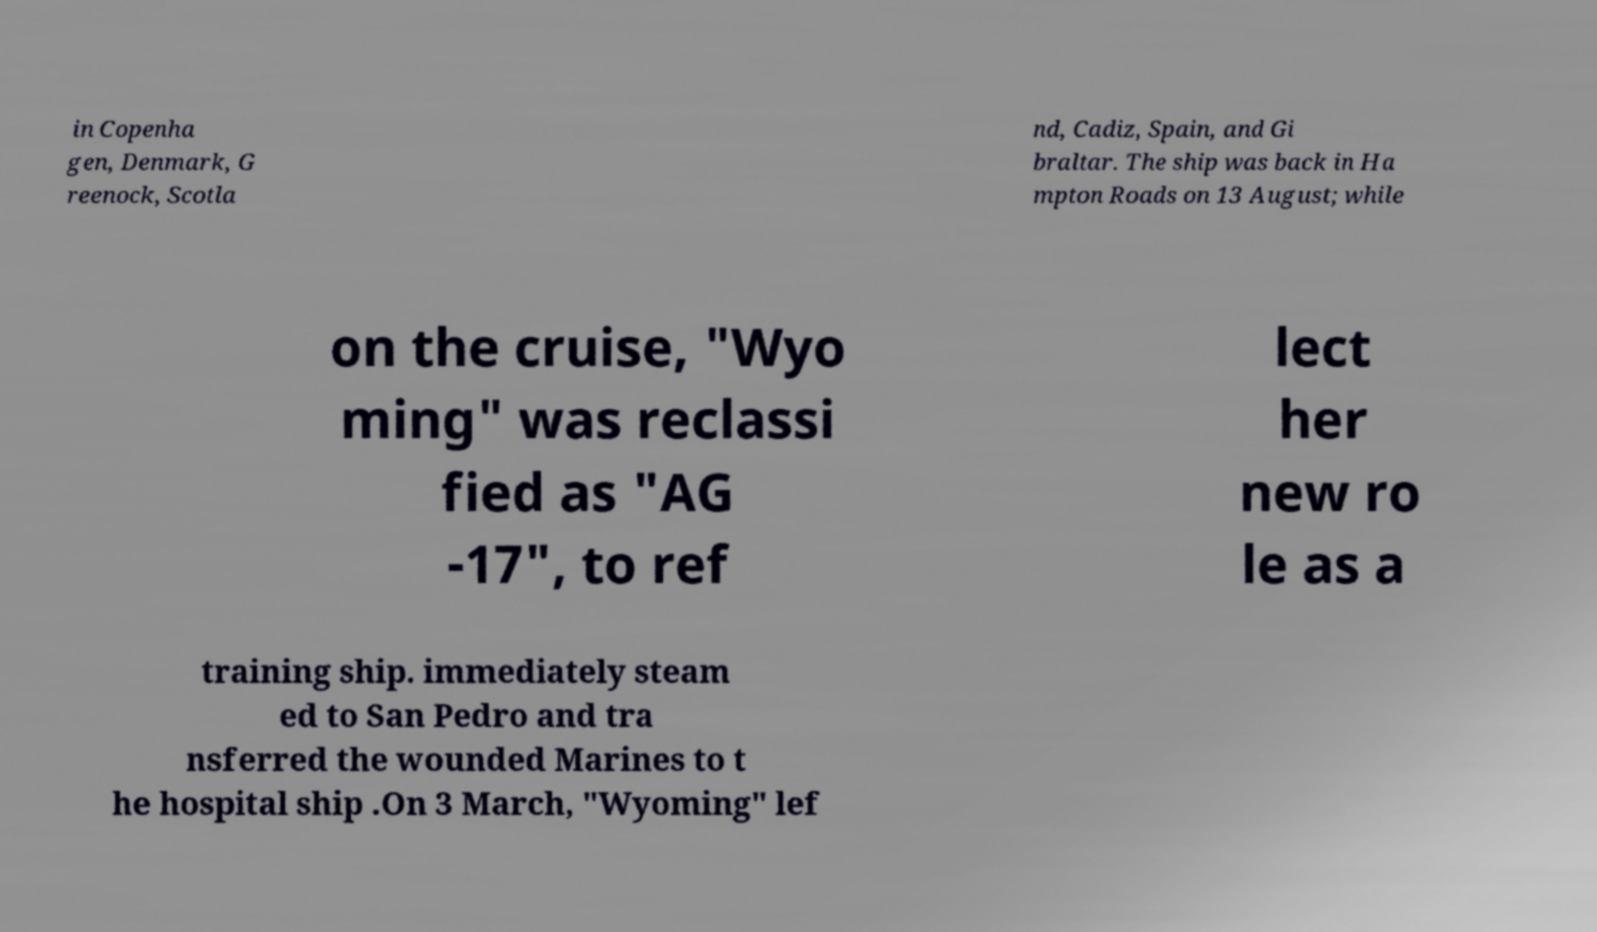Could you assist in decoding the text presented in this image and type it out clearly? in Copenha gen, Denmark, G reenock, Scotla nd, Cadiz, Spain, and Gi braltar. The ship was back in Ha mpton Roads on 13 August; while on the cruise, "Wyo ming" was reclassi fied as "AG -17", to ref lect her new ro le as a training ship. immediately steam ed to San Pedro and tra nsferred the wounded Marines to t he hospital ship .On 3 March, "Wyoming" lef 